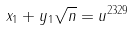<formula> <loc_0><loc_0><loc_500><loc_500>x _ { 1 } + y _ { 1 } \sqrt { n } = u ^ { 2 3 2 9 }</formula> 